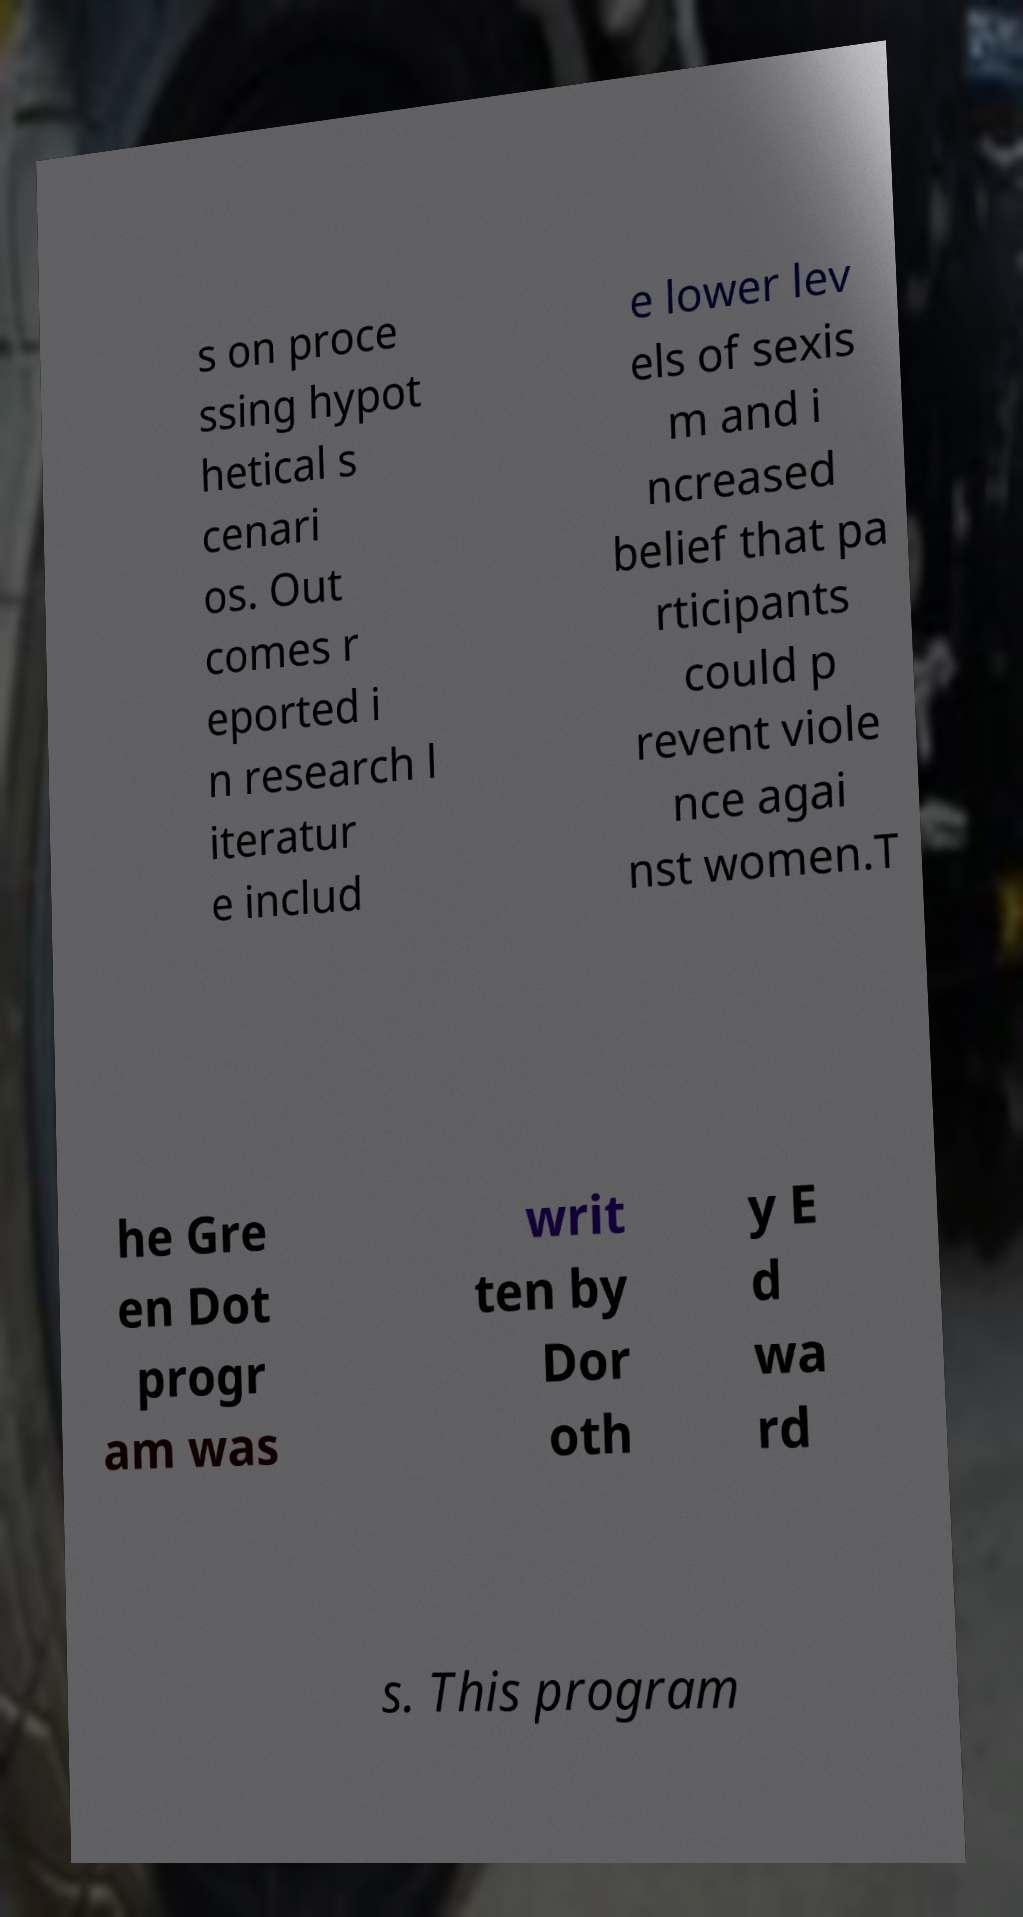What messages or text are displayed in this image? I need them in a readable, typed format. s on proce ssing hypot hetical s cenari os. Out comes r eported i n research l iteratur e includ e lower lev els of sexis m and i ncreased belief that pa rticipants could p revent viole nce agai nst women.T he Gre en Dot progr am was writ ten by Dor oth y E d wa rd s. This program 